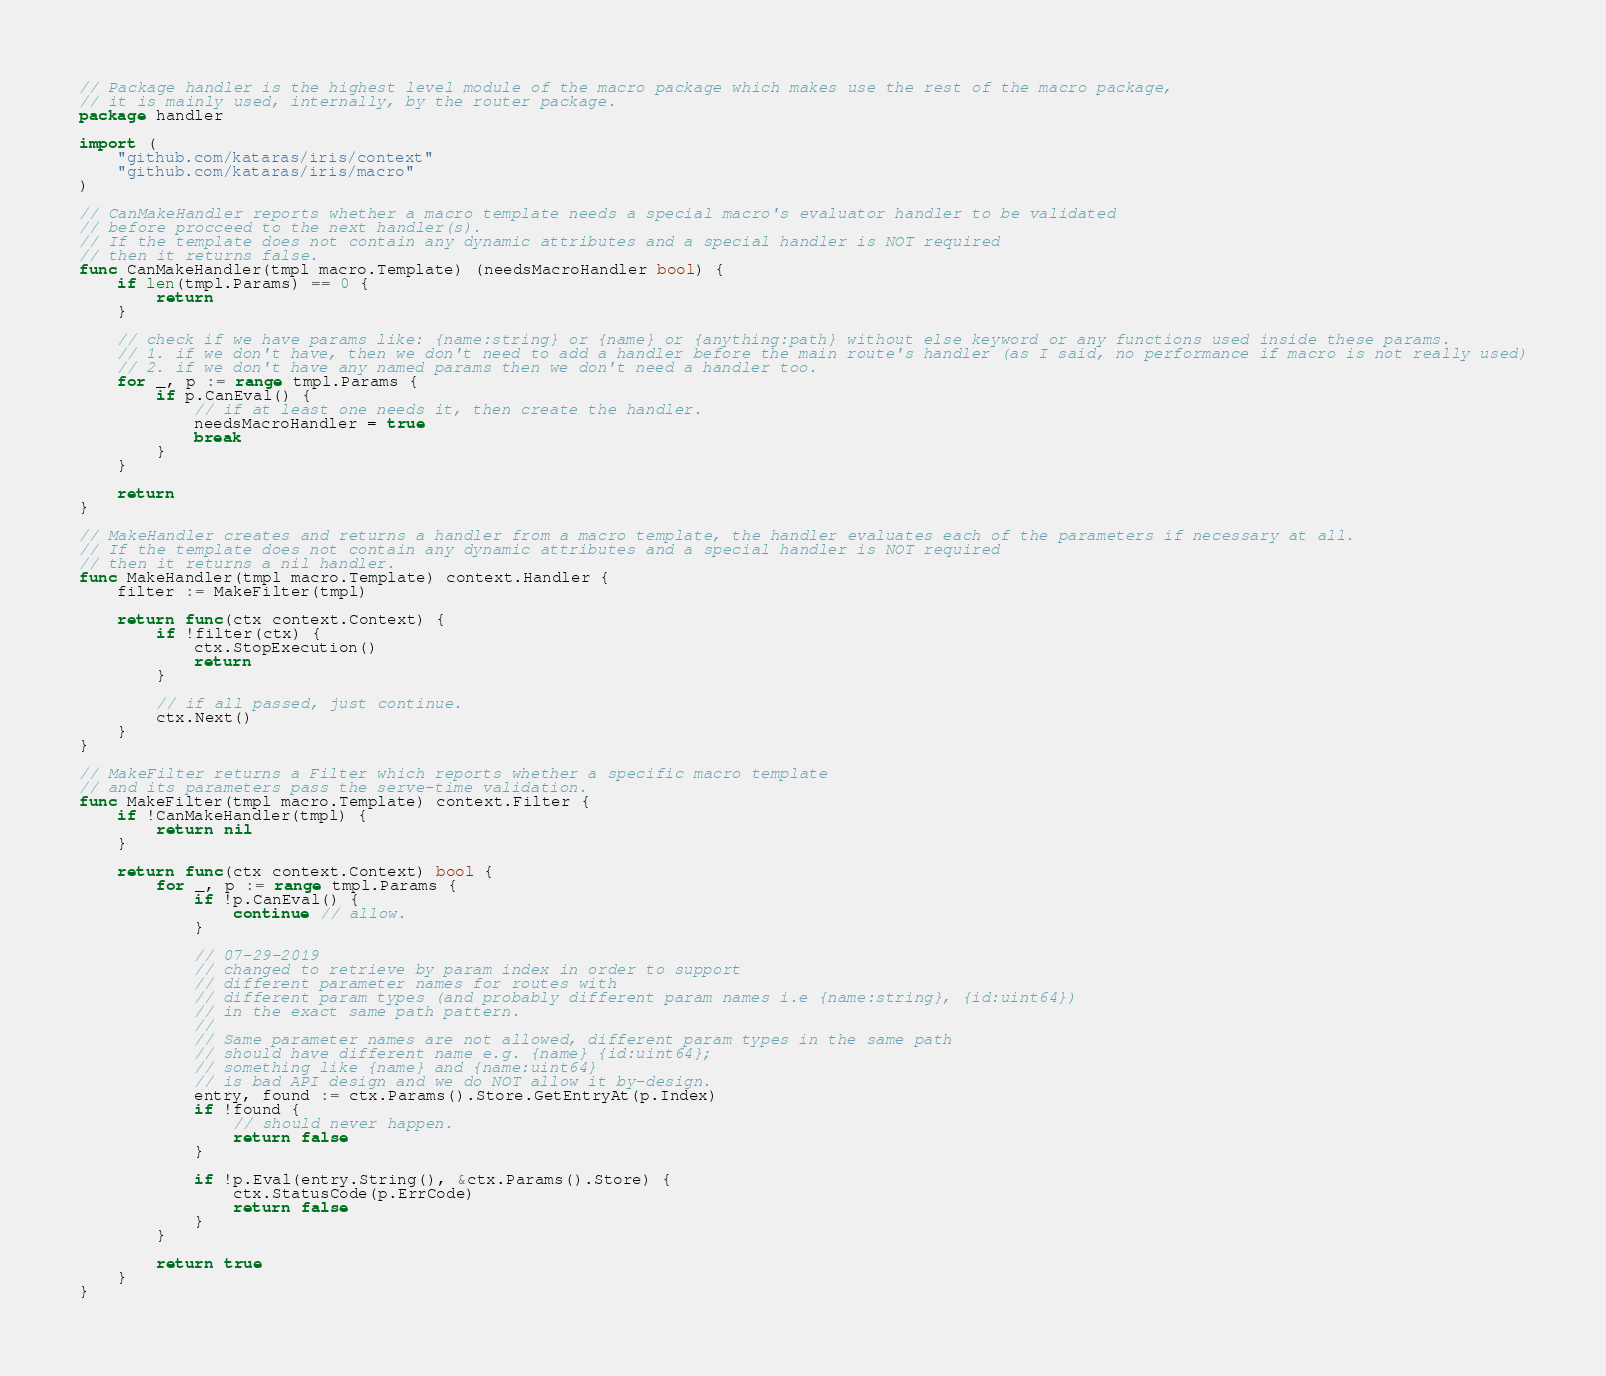<code> <loc_0><loc_0><loc_500><loc_500><_Go_>// Package handler is the highest level module of the macro package which makes use the rest of the macro package,
// it is mainly used, internally, by the router package.
package handler

import (
	"github.com/kataras/iris/context"
	"github.com/kataras/iris/macro"
)

// CanMakeHandler reports whether a macro template needs a special macro's evaluator handler to be validated
// before procceed to the next handler(s).
// If the template does not contain any dynamic attributes and a special handler is NOT required
// then it returns false.
func CanMakeHandler(tmpl macro.Template) (needsMacroHandler bool) {
	if len(tmpl.Params) == 0 {
		return
	}

	// check if we have params like: {name:string} or {name} or {anything:path} without else keyword or any functions used inside these params.
	// 1. if we don't have, then we don't need to add a handler before the main route's handler (as I said, no performance if macro is not really used)
	// 2. if we don't have any named params then we don't need a handler too.
	for _, p := range tmpl.Params {
		if p.CanEval() {
			// if at least one needs it, then create the handler.
			needsMacroHandler = true
			break
		}
	}

	return
}

// MakeHandler creates and returns a handler from a macro template, the handler evaluates each of the parameters if necessary at all.
// If the template does not contain any dynamic attributes and a special handler is NOT required
// then it returns a nil handler.
func MakeHandler(tmpl macro.Template) context.Handler {
	filter := MakeFilter(tmpl)

	return func(ctx context.Context) {
		if !filter(ctx) {
			ctx.StopExecution()
			return
		}

		// if all passed, just continue.
		ctx.Next()
	}
}

// MakeFilter returns a Filter which reports whether a specific macro template
// and its parameters pass the serve-time validation.
func MakeFilter(tmpl macro.Template) context.Filter {
	if !CanMakeHandler(tmpl) {
		return nil
	}

	return func(ctx context.Context) bool {
		for _, p := range tmpl.Params {
			if !p.CanEval() {
				continue // allow.
			}

			// 07-29-2019
			// changed to retrieve by param index in order to support
			// different parameter names for routes with
			// different param types (and probably different param names i.e {name:string}, {id:uint64})
			// in the exact same path pattern.
			//
			// Same parameter names are not allowed, different param types in the same path
			// should have different name e.g. {name} {id:uint64};
			// something like {name} and {name:uint64}
			// is bad API design and we do NOT allow it by-design.
			entry, found := ctx.Params().Store.GetEntryAt(p.Index)
			if !found {
				// should never happen.
				return false
			}

			if !p.Eval(entry.String(), &ctx.Params().Store) {
				ctx.StatusCode(p.ErrCode)
				return false
			}
		}

		return true
	}
}
</code> 